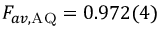<formula> <loc_0><loc_0><loc_500><loc_500>F _ { a v , A Q } = 0 . 9 7 2 ( 4 )</formula> 